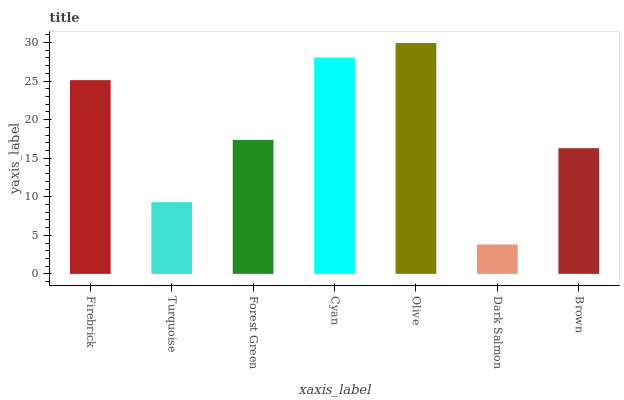Is Dark Salmon the minimum?
Answer yes or no. Yes. Is Olive the maximum?
Answer yes or no. Yes. Is Turquoise the minimum?
Answer yes or no. No. Is Turquoise the maximum?
Answer yes or no. No. Is Firebrick greater than Turquoise?
Answer yes or no. Yes. Is Turquoise less than Firebrick?
Answer yes or no. Yes. Is Turquoise greater than Firebrick?
Answer yes or no. No. Is Firebrick less than Turquoise?
Answer yes or no. No. Is Forest Green the high median?
Answer yes or no. Yes. Is Forest Green the low median?
Answer yes or no. Yes. Is Firebrick the high median?
Answer yes or no. No. Is Turquoise the low median?
Answer yes or no. No. 